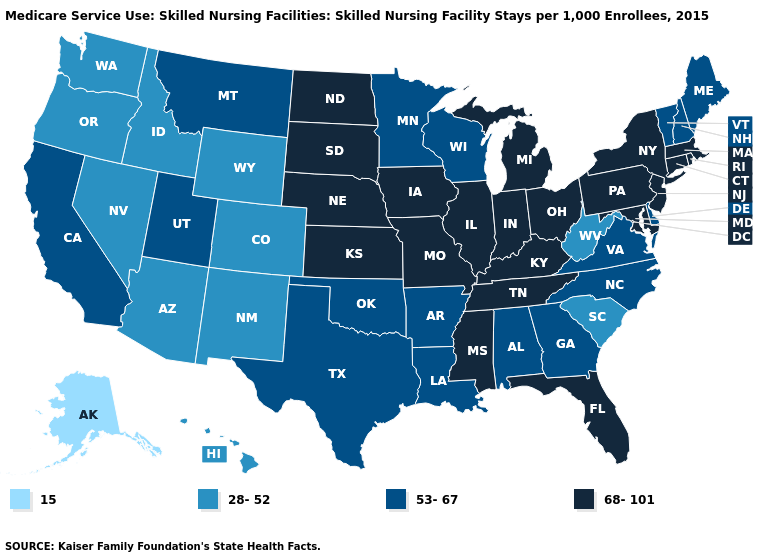Does the first symbol in the legend represent the smallest category?
Keep it brief. Yes. Which states have the lowest value in the West?
Give a very brief answer. Alaska. Does West Virginia have the same value as Florida?
Answer briefly. No. Is the legend a continuous bar?
Give a very brief answer. No. What is the value of North Dakota?
Concise answer only. 68-101. Does New Jersey have the highest value in the USA?
Answer briefly. Yes. What is the value of Texas?
Be succinct. 53-67. Does Alaska have the lowest value in the USA?
Give a very brief answer. Yes. Name the states that have a value in the range 68-101?
Concise answer only. Connecticut, Florida, Illinois, Indiana, Iowa, Kansas, Kentucky, Maryland, Massachusetts, Michigan, Mississippi, Missouri, Nebraska, New Jersey, New York, North Dakota, Ohio, Pennsylvania, Rhode Island, South Dakota, Tennessee. What is the lowest value in the South?
Answer briefly. 28-52. Name the states that have a value in the range 53-67?
Answer briefly. Alabama, Arkansas, California, Delaware, Georgia, Louisiana, Maine, Minnesota, Montana, New Hampshire, North Carolina, Oklahoma, Texas, Utah, Vermont, Virginia, Wisconsin. Name the states that have a value in the range 53-67?
Write a very short answer. Alabama, Arkansas, California, Delaware, Georgia, Louisiana, Maine, Minnesota, Montana, New Hampshire, North Carolina, Oklahoma, Texas, Utah, Vermont, Virginia, Wisconsin. What is the lowest value in states that border Minnesota?
Quick response, please. 53-67. Does Maine have the highest value in the Northeast?
Answer briefly. No. What is the value of Idaho?
Answer briefly. 28-52. 